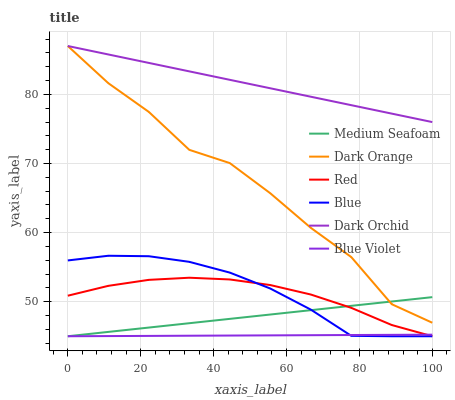Does Blue Violet have the minimum area under the curve?
Answer yes or no. Yes. Does Dark Orchid have the maximum area under the curve?
Answer yes or no. Yes. Does Dark Orange have the minimum area under the curve?
Answer yes or no. No. Does Dark Orange have the maximum area under the curve?
Answer yes or no. No. Is Blue Violet the smoothest?
Answer yes or no. Yes. Is Dark Orange the roughest?
Answer yes or no. Yes. Is Dark Orchid the smoothest?
Answer yes or no. No. Is Dark Orchid the roughest?
Answer yes or no. No. Does Dark Orange have the lowest value?
Answer yes or no. No. Does Dark Orchid have the highest value?
Answer yes or no. Yes. Does Red have the highest value?
Answer yes or no. No. Is Red less than Dark Orchid?
Answer yes or no. Yes. Is Dark Orange greater than Blue Violet?
Answer yes or no. Yes. Does Dark Orange intersect Dark Orchid?
Answer yes or no. Yes. Is Dark Orange less than Dark Orchid?
Answer yes or no. No. Is Dark Orange greater than Dark Orchid?
Answer yes or no. No. Does Red intersect Dark Orchid?
Answer yes or no. No. 